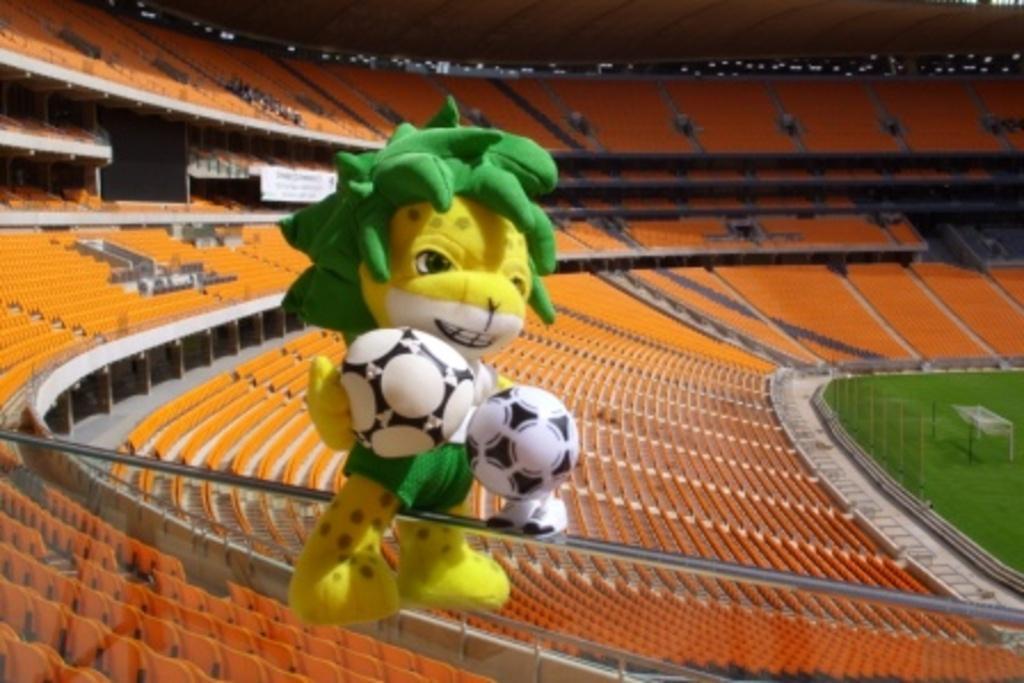How would you summarize this image in a sentence or two? In this image, we can see a stadium. There are seats in the middle of the image. There is a toy on metal rod. 